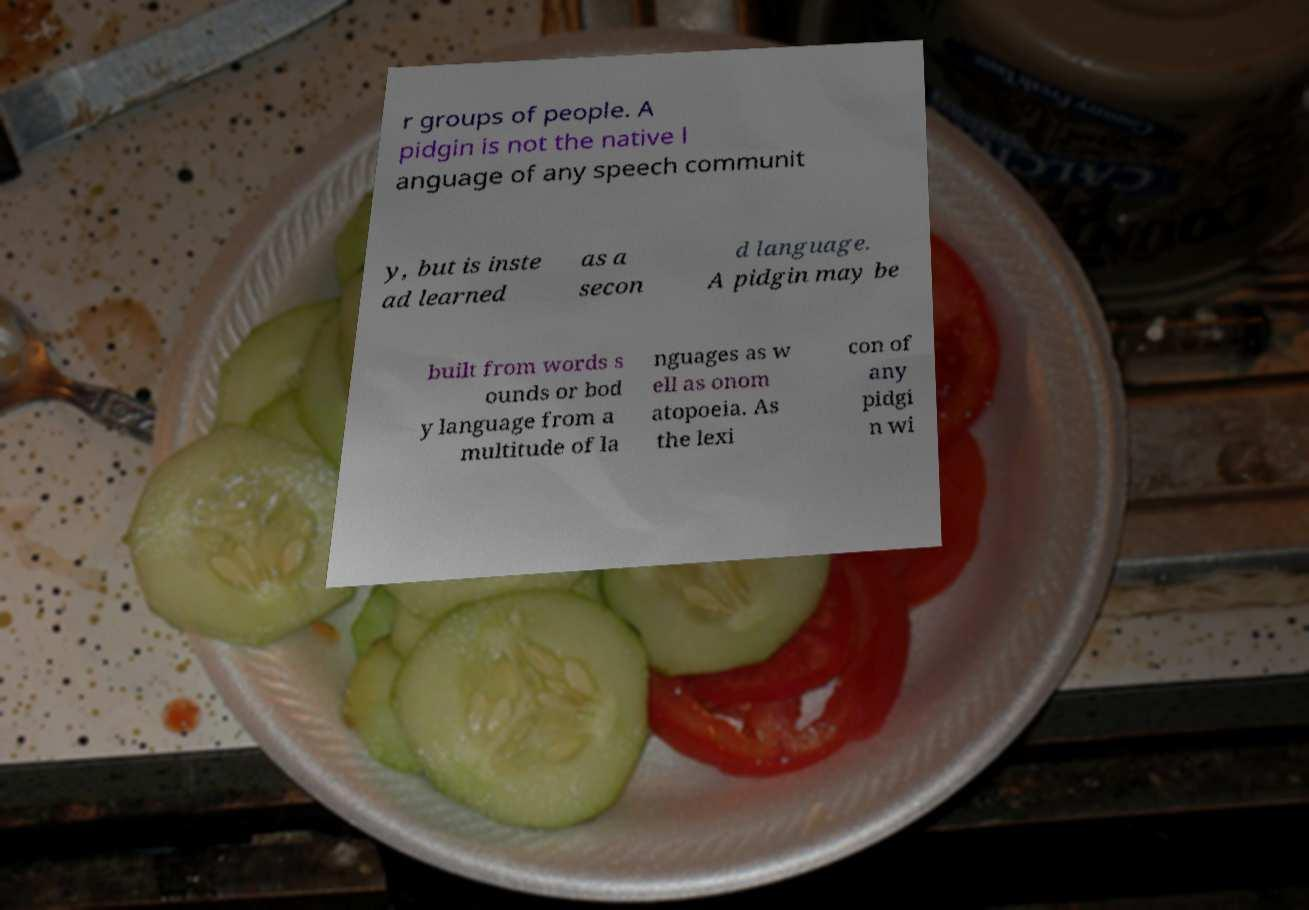What messages or text are displayed in this image? I need them in a readable, typed format. r groups of people. A pidgin is not the native l anguage of any speech communit y, but is inste ad learned as a secon d language. A pidgin may be built from words s ounds or bod y language from a multitude of la nguages as w ell as onom atopoeia. As the lexi con of any pidgi n wi 